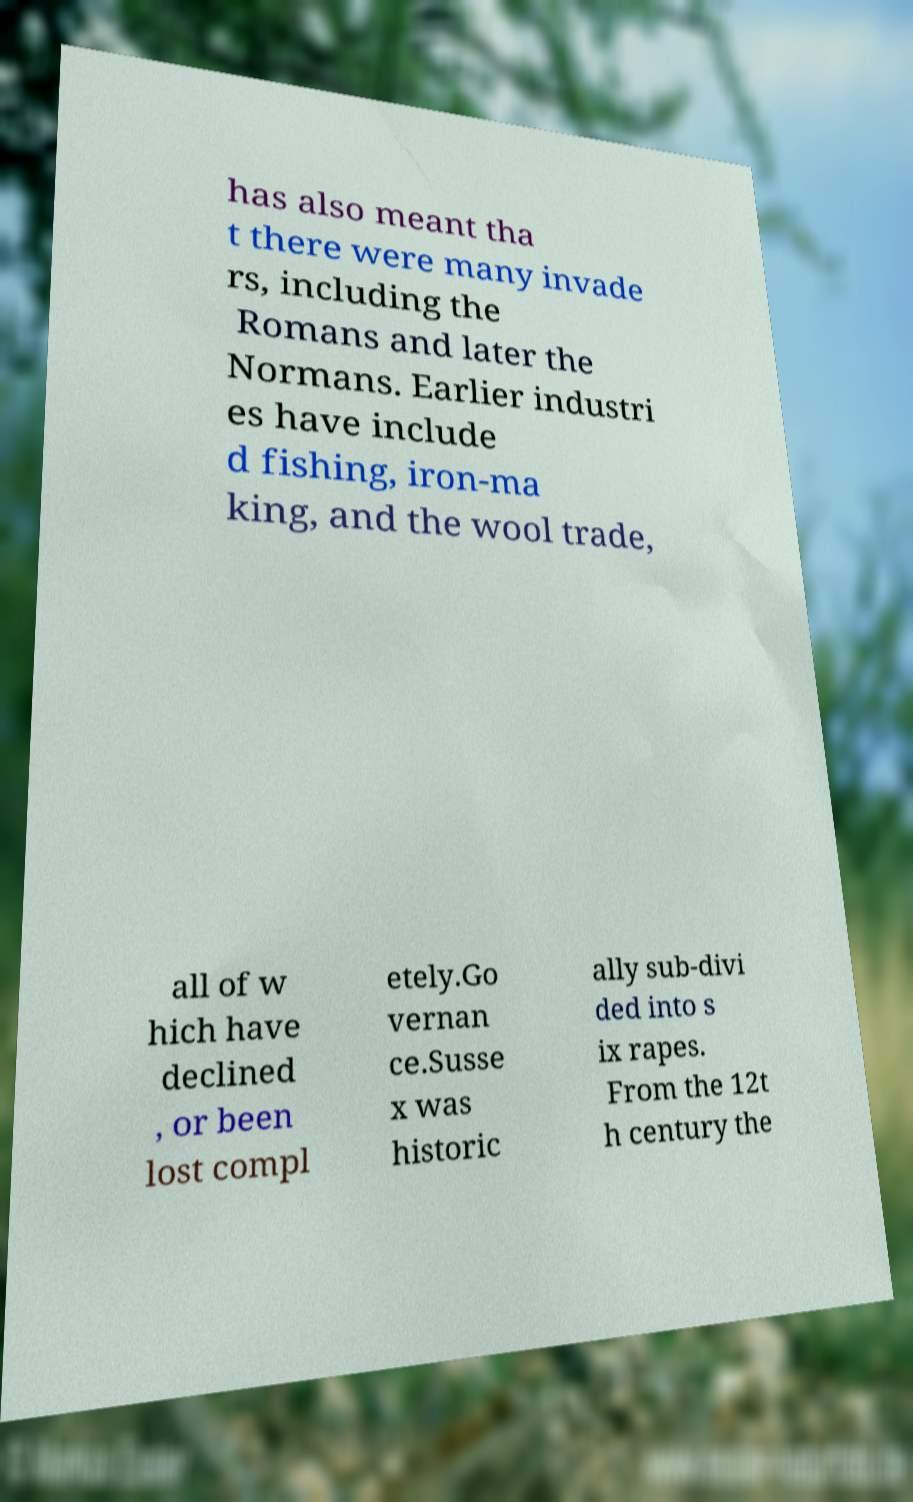I need the written content from this picture converted into text. Can you do that? has also meant tha t there were many invade rs, including the Romans and later the Normans. Earlier industri es have include d fishing, iron-ma king, and the wool trade, all of w hich have declined , or been lost compl etely.Go vernan ce.Susse x was historic ally sub-divi ded into s ix rapes. From the 12t h century the 